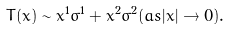<formula> <loc_0><loc_0><loc_500><loc_500>T ( x ) \sim x ^ { 1 } \sigma ^ { 1 } + x ^ { 2 } \sigma ^ { 2 } ( a s | x | \rightarrow 0 ) .</formula> 